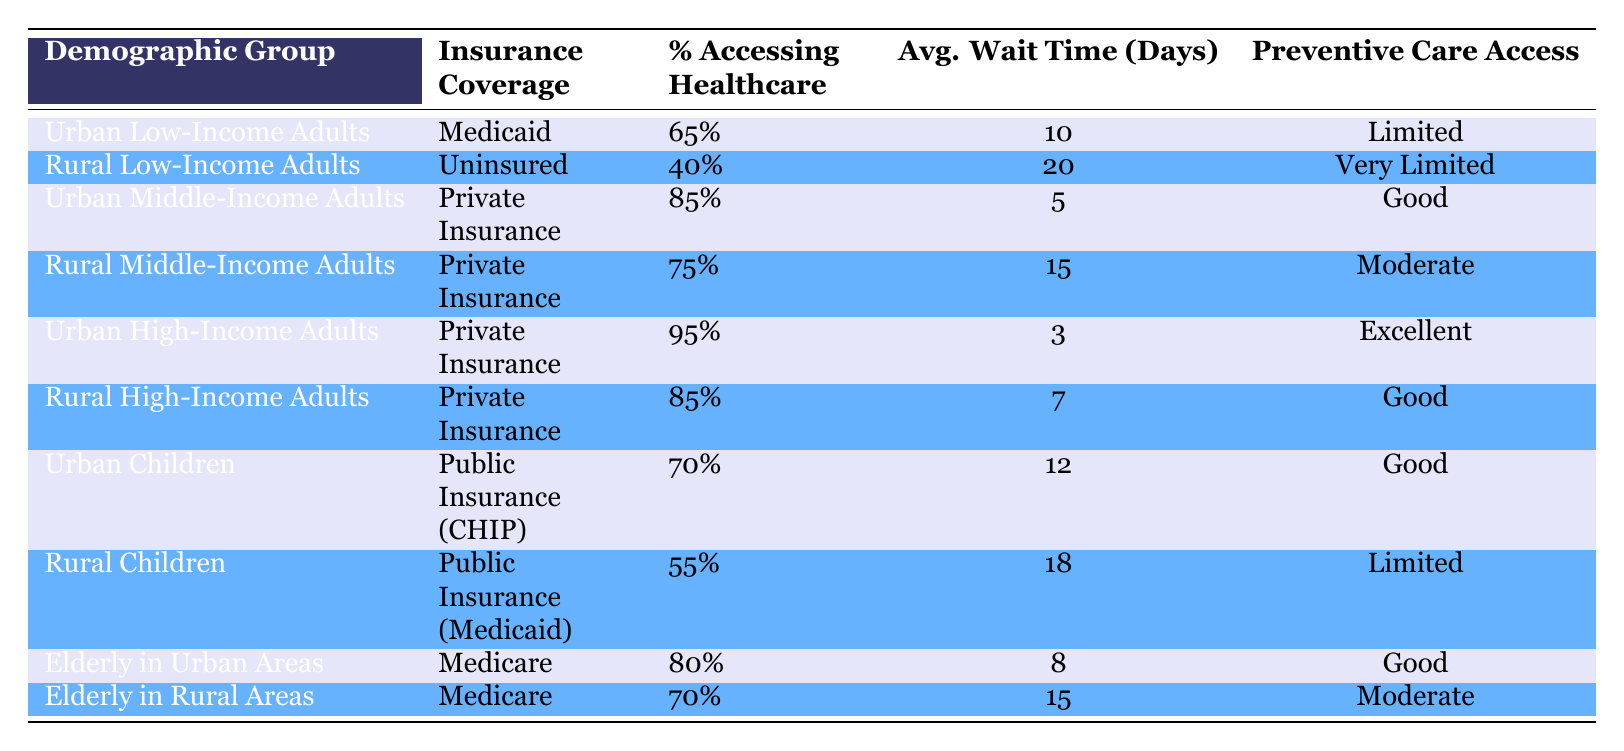What percentage of Urban Low-Income Adults access healthcare services? The table indicates that the percentage accessing healthcare services for Urban Low-Income Adults is 65%.
Answer: 65% What is the average wait time for Rural Middle-Income Adults? According to the table, Rural Middle-Income Adults have an average wait time of 15 days for healthcare services.
Answer: 15 days Do Urban High-Income Adults have excellent access to preventive care? The data shows that Urban High-Income Adults have access to preventive care classified as excellent.
Answer: Yes Which demographic group has the highest percentage accessing healthcare services? From the table, Urban High-Income Adults have the highest percentage of accessing healthcare services at 95%.
Answer: Urban High-Income Adults What is the difference in average wait times between Urban Low-Income Adults and Rural Low-Income Adults? The average wait time for Urban Low-Income Adults is 10 days and for Rural Low-Income Adults is 20 days. The difference is 20 - 10 = 10 days.
Answer: 10 days Are there more children accessing healthcare services in urban areas than in rural areas? The percentage for Urban Children accessing healthcare services is 70%, while for Rural Children it is 55%. This indicates that more Urban Children access services.
Answer: Yes What is the average percentage of access to healthcare services for Elderly in Urban Areas and Rural Areas combined? The percentage for Elderly in Urban Areas is 80% and for Elderly in Rural Areas is 70%. The average is (80 + 70) / 2 = 75%.
Answer: 75% Is the preventive care access for Rural Children very limited? The preventive care access for Rural Children is classified as limited, not very limited.
Answer: No Which demographic group with private insurance has the longest average wait time? Rural Middle-Income Adults, who have private insurance, experience an average wait time of 15 days, which is longer than Urban High-Income Adults and Urban Middle-Income Adults, who both have shorter wait times.
Answer: Rural Middle-Income Adults 